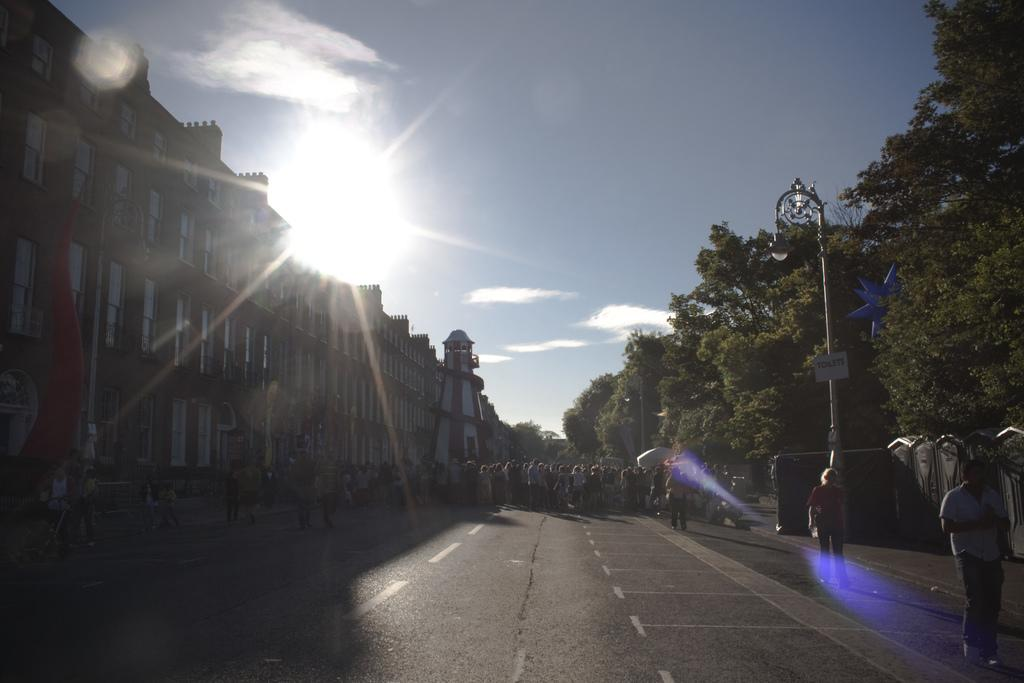What type of structures can be seen in the image? There are buildings in the image. Who or what else is present in the image? There are people and trees in the image. Can you describe any specific features of the image? There is a street light on the right side of the image, and the sun and sky are visible in the background. What type of fruit can be seen hanging from the trees in the image? There is no fruit hanging from the trees in the image; only the trees themselves are visible. What type of flowers are growing near the street light in the image? There are no flowers present in the image; only trees, buildings, people, and a street light are visible. 